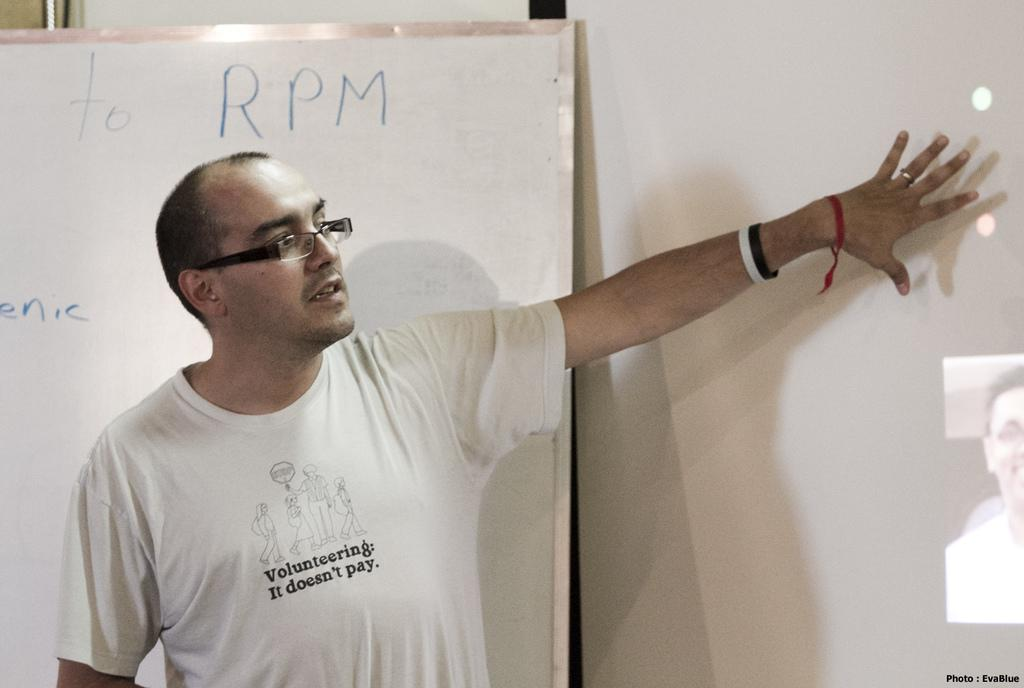Who is present in the image? There is a man in the image. What is the man wearing? The man is wearing a white t-shirt. What can be seen on the screen in the image? The screen displays a picture of a person. What other object is present in the image? There is a whiteboard in the image. What type of bone can be seen on the whiteboard in the image? There is no bone present on the whiteboard in the image. 